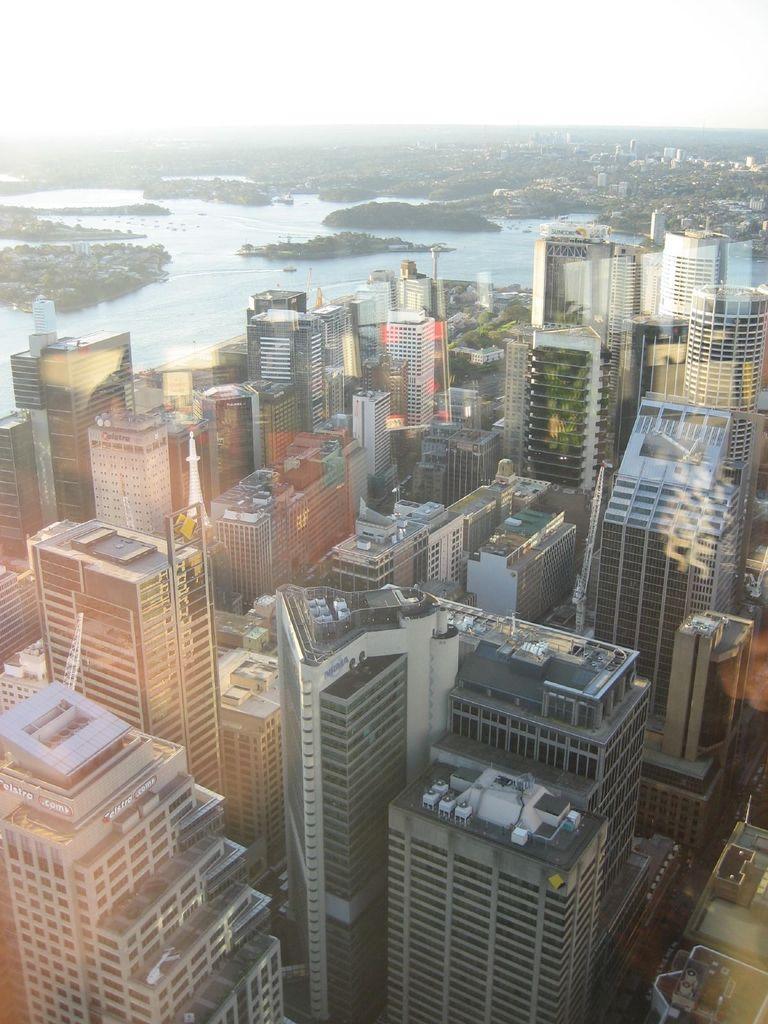Can you describe this image briefly? In this picture we can see buildings in the front, in the background there is water, we can see the sky at the top of the picture. 